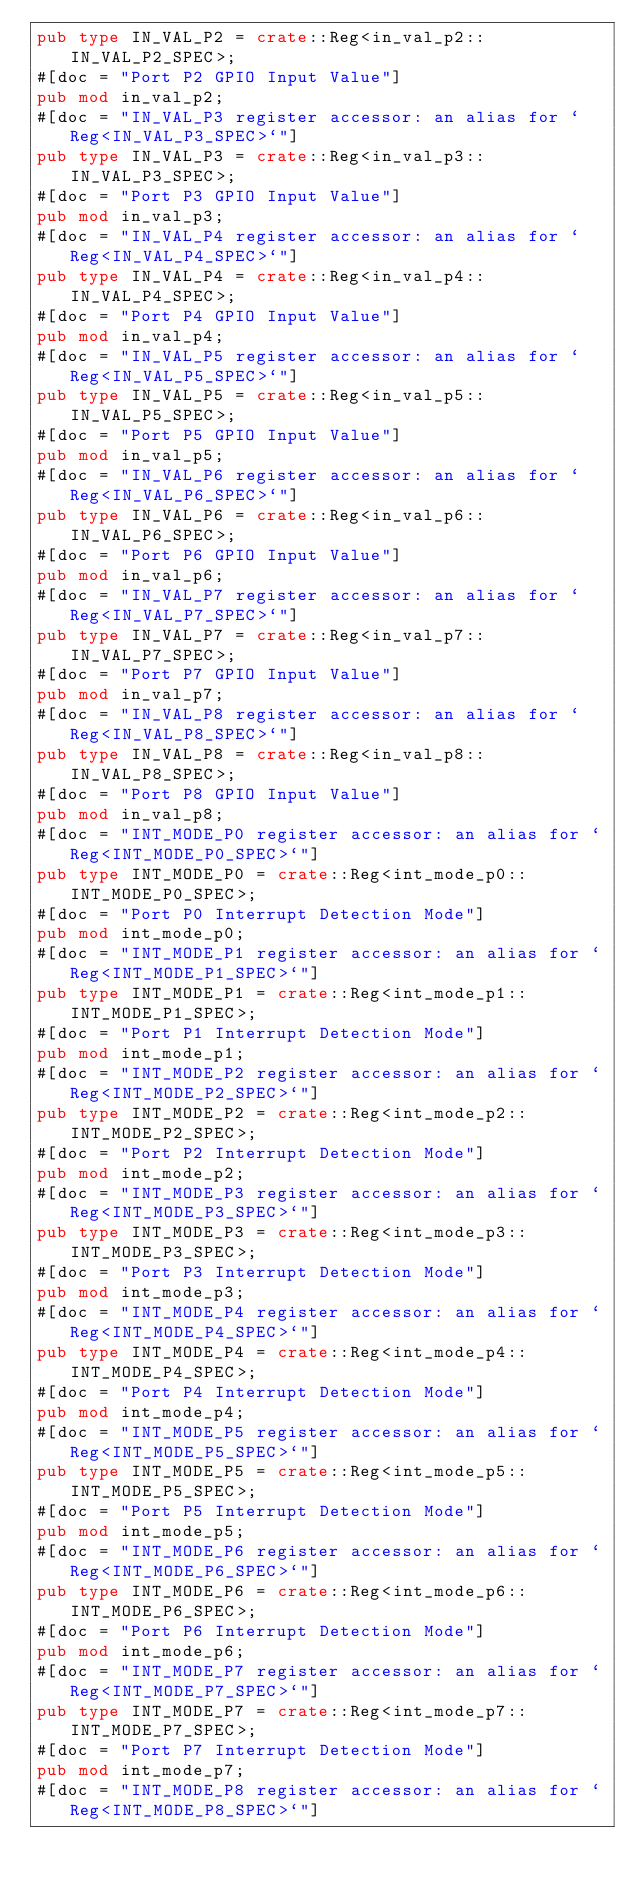<code> <loc_0><loc_0><loc_500><loc_500><_Rust_>pub type IN_VAL_P2 = crate::Reg<in_val_p2::IN_VAL_P2_SPEC>;
#[doc = "Port P2 GPIO Input Value"]
pub mod in_val_p2;
#[doc = "IN_VAL_P3 register accessor: an alias for `Reg<IN_VAL_P3_SPEC>`"]
pub type IN_VAL_P3 = crate::Reg<in_val_p3::IN_VAL_P3_SPEC>;
#[doc = "Port P3 GPIO Input Value"]
pub mod in_val_p3;
#[doc = "IN_VAL_P4 register accessor: an alias for `Reg<IN_VAL_P4_SPEC>`"]
pub type IN_VAL_P4 = crate::Reg<in_val_p4::IN_VAL_P4_SPEC>;
#[doc = "Port P4 GPIO Input Value"]
pub mod in_val_p4;
#[doc = "IN_VAL_P5 register accessor: an alias for `Reg<IN_VAL_P5_SPEC>`"]
pub type IN_VAL_P5 = crate::Reg<in_val_p5::IN_VAL_P5_SPEC>;
#[doc = "Port P5 GPIO Input Value"]
pub mod in_val_p5;
#[doc = "IN_VAL_P6 register accessor: an alias for `Reg<IN_VAL_P6_SPEC>`"]
pub type IN_VAL_P6 = crate::Reg<in_val_p6::IN_VAL_P6_SPEC>;
#[doc = "Port P6 GPIO Input Value"]
pub mod in_val_p6;
#[doc = "IN_VAL_P7 register accessor: an alias for `Reg<IN_VAL_P7_SPEC>`"]
pub type IN_VAL_P7 = crate::Reg<in_val_p7::IN_VAL_P7_SPEC>;
#[doc = "Port P7 GPIO Input Value"]
pub mod in_val_p7;
#[doc = "IN_VAL_P8 register accessor: an alias for `Reg<IN_VAL_P8_SPEC>`"]
pub type IN_VAL_P8 = crate::Reg<in_val_p8::IN_VAL_P8_SPEC>;
#[doc = "Port P8 GPIO Input Value"]
pub mod in_val_p8;
#[doc = "INT_MODE_P0 register accessor: an alias for `Reg<INT_MODE_P0_SPEC>`"]
pub type INT_MODE_P0 = crate::Reg<int_mode_p0::INT_MODE_P0_SPEC>;
#[doc = "Port P0 Interrupt Detection Mode"]
pub mod int_mode_p0;
#[doc = "INT_MODE_P1 register accessor: an alias for `Reg<INT_MODE_P1_SPEC>`"]
pub type INT_MODE_P1 = crate::Reg<int_mode_p1::INT_MODE_P1_SPEC>;
#[doc = "Port P1 Interrupt Detection Mode"]
pub mod int_mode_p1;
#[doc = "INT_MODE_P2 register accessor: an alias for `Reg<INT_MODE_P2_SPEC>`"]
pub type INT_MODE_P2 = crate::Reg<int_mode_p2::INT_MODE_P2_SPEC>;
#[doc = "Port P2 Interrupt Detection Mode"]
pub mod int_mode_p2;
#[doc = "INT_MODE_P3 register accessor: an alias for `Reg<INT_MODE_P3_SPEC>`"]
pub type INT_MODE_P3 = crate::Reg<int_mode_p3::INT_MODE_P3_SPEC>;
#[doc = "Port P3 Interrupt Detection Mode"]
pub mod int_mode_p3;
#[doc = "INT_MODE_P4 register accessor: an alias for `Reg<INT_MODE_P4_SPEC>`"]
pub type INT_MODE_P4 = crate::Reg<int_mode_p4::INT_MODE_P4_SPEC>;
#[doc = "Port P4 Interrupt Detection Mode"]
pub mod int_mode_p4;
#[doc = "INT_MODE_P5 register accessor: an alias for `Reg<INT_MODE_P5_SPEC>`"]
pub type INT_MODE_P5 = crate::Reg<int_mode_p5::INT_MODE_P5_SPEC>;
#[doc = "Port P5 Interrupt Detection Mode"]
pub mod int_mode_p5;
#[doc = "INT_MODE_P6 register accessor: an alias for `Reg<INT_MODE_P6_SPEC>`"]
pub type INT_MODE_P6 = crate::Reg<int_mode_p6::INT_MODE_P6_SPEC>;
#[doc = "Port P6 Interrupt Detection Mode"]
pub mod int_mode_p6;
#[doc = "INT_MODE_P7 register accessor: an alias for `Reg<INT_MODE_P7_SPEC>`"]
pub type INT_MODE_P7 = crate::Reg<int_mode_p7::INT_MODE_P7_SPEC>;
#[doc = "Port P7 Interrupt Detection Mode"]
pub mod int_mode_p7;
#[doc = "INT_MODE_P8 register accessor: an alias for `Reg<INT_MODE_P8_SPEC>`"]</code> 